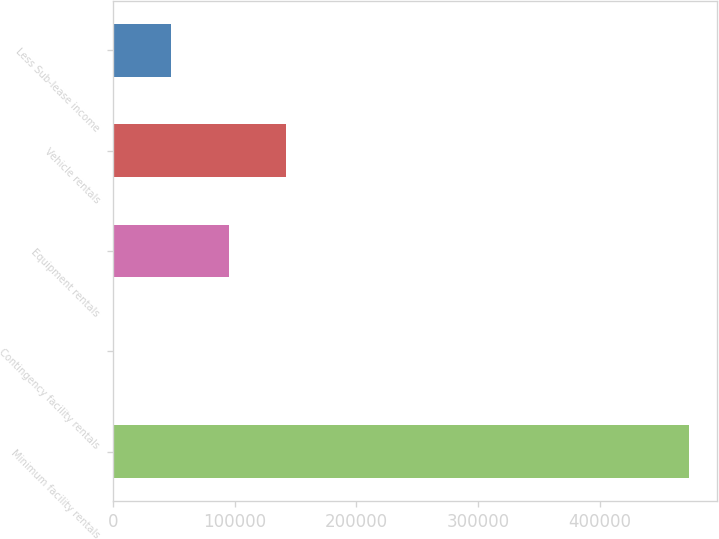<chart> <loc_0><loc_0><loc_500><loc_500><bar_chart><fcel>Minimum facility rentals<fcel>Contingency facility rentals<fcel>Equipment rentals<fcel>Vehicle rentals<fcel>Less Sub-lease income<nl><fcel>473156<fcel>440<fcel>94983.2<fcel>142255<fcel>47711.6<nl></chart> 